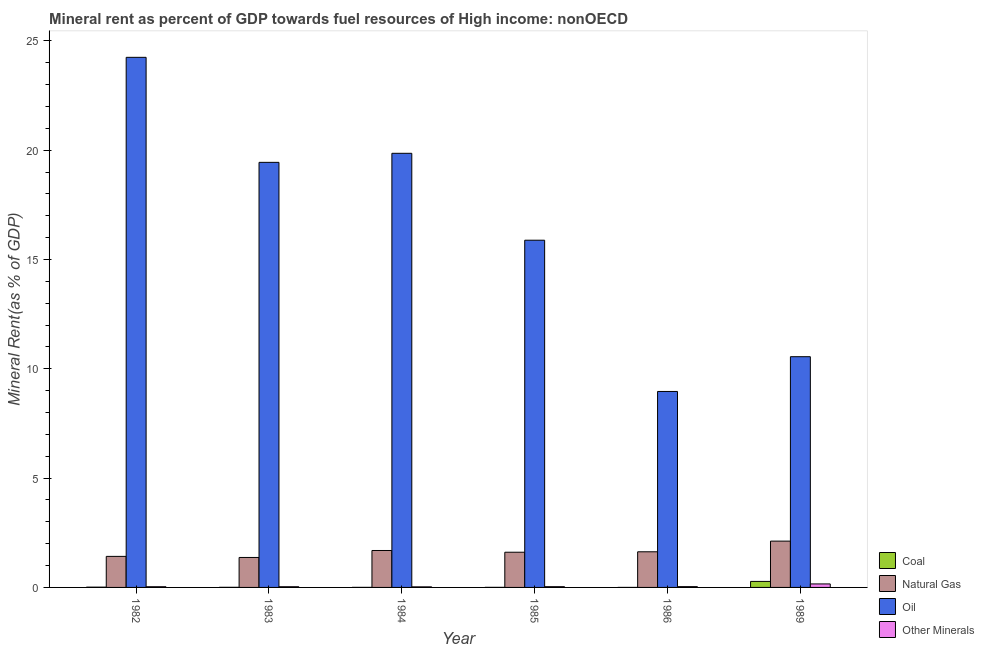How many groups of bars are there?
Keep it short and to the point. 6. Are the number of bars on each tick of the X-axis equal?
Ensure brevity in your answer.  Yes. How many bars are there on the 1st tick from the left?
Your answer should be very brief. 4. How many bars are there on the 3rd tick from the right?
Provide a succinct answer. 4. What is the label of the 1st group of bars from the left?
Your answer should be compact. 1982. In how many cases, is the number of bars for a given year not equal to the number of legend labels?
Your answer should be very brief. 0. What is the oil rent in 1986?
Keep it short and to the point. 8.96. Across all years, what is the maximum natural gas rent?
Keep it short and to the point. 2.12. Across all years, what is the minimum natural gas rent?
Your answer should be compact. 1.37. In which year was the natural gas rent maximum?
Make the answer very short. 1989. What is the total oil rent in the graph?
Offer a terse response. 98.95. What is the difference between the coal rent in 1983 and that in 1986?
Offer a very short reply. 0. What is the difference between the coal rent in 1989 and the oil rent in 1984?
Your answer should be compact. 0.27. What is the average  rent of other minerals per year?
Make the answer very short. 0.05. In the year 1989, what is the difference between the  rent of other minerals and natural gas rent?
Your answer should be very brief. 0. What is the ratio of the coal rent in 1984 to that in 1989?
Offer a terse response. 0.01. Is the coal rent in 1983 less than that in 1986?
Provide a short and direct response. No. What is the difference between the highest and the second highest natural gas rent?
Your response must be concise. 0.43. What is the difference between the highest and the lowest natural gas rent?
Provide a short and direct response. 0.75. In how many years, is the natural gas rent greater than the average natural gas rent taken over all years?
Your response must be concise. 2. Is the sum of the oil rent in 1985 and 1986 greater than the maximum coal rent across all years?
Offer a terse response. Yes. Is it the case that in every year, the sum of the oil rent and coal rent is greater than the sum of natural gas rent and  rent of other minerals?
Ensure brevity in your answer.  Yes. What does the 4th bar from the left in 1989 represents?
Make the answer very short. Other Minerals. What does the 3rd bar from the right in 1982 represents?
Your answer should be compact. Natural Gas. Is it the case that in every year, the sum of the coal rent and natural gas rent is greater than the oil rent?
Your answer should be very brief. No. How many years are there in the graph?
Ensure brevity in your answer.  6. What is the difference between two consecutive major ticks on the Y-axis?
Offer a very short reply. 5. Are the values on the major ticks of Y-axis written in scientific E-notation?
Your answer should be compact. No. Does the graph contain grids?
Your response must be concise. No. What is the title of the graph?
Offer a very short reply. Mineral rent as percent of GDP towards fuel resources of High income: nonOECD. What is the label or title of the Y-axis?
Your answer should be very brief. Mineral Rent(as % of GDP). What is the Mineral Rent(as % of GDP) of Coal in 1982?
Your answer should be compact. 0.01. What is the Mineral Rent(as % of GDP) of Natural Gas in 1982?
Offer a terse response. 1.42. What is the Mineral Rent(as % of GDP) of Oil in 1982?
Your answer should be very brief. 24.25. What is the Mineral Rent(as % of GDP) of Other Minerals in 1982?
Make the answer very short. 0.03. What is the Mineral Rent(as % of GDP) in Coal in 1983?
Offer a very short reply. 0. What is the Mineral Rent(as % of GDP) in Natural Gas in 1983?
Your response must be concise. 1.37. What is the Mineral Rent(as % of GDP) in Oil in 1983?
Your answer should be very brief. 19.44. What is the Mineral Rent(as % of GDP) in Other Minerals in 1983?
Make the answer very short. 0.03. What is the Mineral Rent(as % of GDP) of Coal in 1984?
Your response must be concise. 0. What is the Mineral Rent(as % of GDP) of Natural Gas in 1984?
Make the answer very short. 1.69. What is the Mineral Rent(as % of GDP) in Oil in 1984?
Make the answer very short. 19.86. What is the Mineral Rent(as % of GDP) in Other Minerals in 1984?
Keep it short and to the point. 0.03. What is the Mineral Rent(as % of GDP) in Coal in 1985?
Offer a very short reply. 0. What is the Mineral Rent(as % of GDP) of Natural Gas in 1985?
Your answer should be compact. 1.61. What is the Mineral Rent(as % of GDP) of Oil in 1985?
Your response must be concise. 15.88. What is the Mineral Rent(as % of GDP) in Other Minerals in 1985?
Offer a very short reply. 0.03. What is the Mineral Rent(as % of GDP) of Coal in 1986?
Give a very brief answer. 0. What is the Mineral Rent(as % of GDP) in Natural Gas in 1986?
Make the answer very short. 1.63. What is the Mineral Rent(as % of GDP) in Oil in 1986?
Keep it short and to the point. 8.96. What is the Mineral Rent(as % of GDP) of Other Minerals in 1986?
Your answer should be very brief. 0.04. What is the Mineral Rent(as % of GDP) in Coal in 1989?
Ensure brevity in your answer.  0.27. What is the Mineral Rent(as % of GDP) of Natural Gas in 1989?
Ensure brevity in your answer.  2.12. What is the Mineral Rent(as % of GDP) in Oil in 1989?
Keep it short and to the point. 10.55. What is the Mineral Rent(as % of GDP) in Other Minerals in 1989?
Offer a very short reply. 0.16. Across all years, what is the maximum Mineral Rent(as % of GDP) in Coal?
Give a very brief answer. 0.27. Across all years, what is the maximum Mineral Rent(as % of GDP) of Natural Gas?
Give a very brief answer. 2.12. Across all years, what is the maximum Mineral Rent(as % of GDP) in Oil?
Provide a short and direct response. 24.25. Across all years, what is the maximum Mineral Rent(as % of GDP) in Other Minerals?
Keep it short and to the point. 0.16. Across all years, what is the minimum Mineral Rent(as % of GDP) of Coal?
Offer a very short reply. 0. Across all years, what is the minimum Mineral Rent(as % of GDP) in Natural Gas?
Provide a succinct answer. 1.37. Across all years, what is the minimum Mineral Rent(as % of GDP) of Oil?
Your answer should be very brief. 8.96. Across all years, what is the minimum Mineral Rent(as % of GDP) of Other Minerals?
Your answer should be compact. 0.03. What is the total Mineral Rent(as % of GDP) in Coal in the graph?
Provide a succinct answer. 0.3. What is the total Mineral Rent(as % of GDP) in Natural Gas in the graph?
Offer a terse response. 9.84. What is the total Mineral Rent(as % of GDP) in Oil in the graph?
Ensure brevity in your answer.  98.95. What is the total Mineral Rent(as % of GDP) in Other Minerals in the graph?
Keep it short and to the point. 0.32. What is the difference between the Mineral Rent(as % of GDP) of Coal in 1982 and that in 1983?
Offer a terse response. 0.01. What is the difference between the Mineral Rent(as % of GDP) in Natural Gas in 1982 and that in 1983?
Provide a succinct answer. 0.05. What is the difference between the Mineral Rent(as % of GDP) in Oil in 1982 and that in 1983?
Offer a terse response. 4.8. What is the difference between the Mineral Rent(as % of GDP) of Coal in 1982 and that in 1984?
Offer a very short reply. 0.01. What is the difference between the Mineral Rent(as % of GDP) of Natural Gas in 1982 and that in 1984?
Your response must be concise. -0.27. What is the difference between the Mineral Rent(as % of GDP) in Oil in 1982 and that in 1984?
Your response must be concise. 4.39. What is the difference between the Mineral Rent(as % of GDP) of Other Minerals in 1982 and that in 1984?
Provide a succinct answer. 0.01. What is the difference between the Mineral Rent(as % of GDP) of Coal in 1982 and that in 1985?
Your response must be concise. 0.01. What is the difference between the Mineral Rent(as % of GDP) of Natural Gas in 1982 and that in 1985?
Keep it short and to the point. -0.19. What is the difference between the Mineral Rent(as % of GDP) in Oil in 1982 and that in 1985?
Your answer should be very brief. 8.36. What is the difference between the Mineral Rent(as % of GDP) in Other Minerals in 1982 and that in 1985?
Your answer should be very brief. -0. What is the difference between the Mineral Rent(as % of GDP) in Coal in 1982 and that in 1986?
Ensure brevity in your answer.  0.01. What is the difference between the Mineral Rent(as % of GDP) in Natural Gas in 1982 and that in 1986?
Offer a terse response. -0.21. What is the difference between the Mineral Rent(as % of GDP) in Oil in 1982 and that in 1986?
Make the answer very short. 15.28. What is the difference between the Mineral Rent(as % of GDP) in Other Minerals in 1982 and that in 1986?
Ensure brevity in your answer.  -0. What is the difference between the Mineral Rent(as % of GDP) in Coal in 1982 and that in 1989?
Give a very brief answer. -0.26. What is the difference between the Mineral Rent(as % of GDP) of Natural Gas in 1982 and that in 1989?
Ensure brevity in your answer.  -0.7. What is the difference between the Mineral Rent(as % of GDP) of Oil in 1982 and that in 1989?
Keep it short and to the point. 13.69. What is the difference between the Mineral Rent(as % of GDP) of Other Minerals in 1982 and that in 1989?
Your answer should be compact. -0.13. What is the difference between the Mineral Rent(as % of GDP) in Coal in 1983 and that in 1984?
Give a very brief answer. 0. What is the difference between the Mineral Rent(as % of GDP) of Natural Gas in 1983 and that in 1984?
Your answer should be compact. -0.32. What is the difference between the Mineral Rent(as % of GDP) of Oil in 1983 and that in 1984?
Offer a terse response. -0.41. What is the difference between the Mineral Rent(as % of GDP) in Other Minerals in 1983 and that in 1984?
Offer a very short reply. 0.01. What is the difference between the Mineral Rent(as % of GDP) in Coal in 1983 and that in 1985?
Your response must be concise. 0. What is the difference between the Mineral Rent(as % of GDP) in Natural Gas in 1983 and that in 1985?
Keep it short and to the point. -0.24. What is the difference between the Mineral Rent(as % of GDP) of Oil in 1983 and that in 1985?
Ensure brevity in your answer.  3.56. What is the difference between the Mineral Rent(as % of GDP) in Other Minerals in 1983 and that in 1985?
Your response must be concise. -0. What is the difference between the Mineral Rent(as % of GDP) of Coal in 1983 and that in 1986?
Make the answer very short. 0. What is the difference between the Mineral Rent(as % of GDP) in Natural Gas in 1983 and that in 1986?
Offer a very short reply. -0.26. What is the difference between the Mineral Rent(as % of GDP) of Oil in 1983 and that in 1986?
Offer a terse response. 10.48. What is the difference between the Mineral Rent(as % of GDP) in Other Minerals in 1983 and that in 1986?
Keep it short and to the point. -0. What is the difference between the Mineral Rent(as % of GDP) in Coal in 1983 and that in 1989?
Make the answer very short. -0.27. What is the difference between the Mineral Rent(as % of GDP) of Natural Gas in 1983 and that in 1989?
Offer a very short reply. -0.75. What is the difference between the Mineral Rent(as % of GDP) in Oil in 1983 and that in 1989?
Offer a very short reply. 8.89. What is the difference between the Mineral Rent(as % of GDP) in Other Minerals in 1983 and that in 1989?
Your answer should be compact. -0.13. What is the difference between the Mineral Rent(as % of GDP) in Coal in 1984 and that in 1985?
Your response must be concise. -0. What is the difference between the Mineral Rent(as % of GDP) in Natural Gas in 1984 and that in 1985?
Your response must be concise. 0.08. What is the difference between the Mineral Rent(as % of GDP) of Oil in 1984 and that in 1985?
Your answer should be very brief. 3.97. What is the difference between the Mineral Rent(as % of GDP) in Other Minerals in 1984 and that in 1985?
Offer a terse response. -0.01. What is the difference between the Mineral Rent(as % of GDP) in Coal in 1984 and that in 1986?
Your answer should be compact. 0. What is the difference between the Mineral Rent(as % of GDP) in Natural Gas in 1984 and that in 1986?
Your answer should be compact. 0.06. What is the difference between the Mineral Rent(as % of GDP) of Oil in 1984 and that in 1986?
Ensure brevity in your answer.  10.89. What is the difference between the Mineral Rent(as % of GDP) of Other Minerals in 1984 and that in 1986?
Provide a succinct answer. -0.01. What is the difference between the Mineral Rent(as % of GDP) in Coal in 1984 and that in 1989?
Your answer should be compact. -0.27. What is the difference between the Mineral Rent(as % of GDP) of Natural Gas in 1984 and that in 1989?
Provide a short and direct response. -0.43. What is the difference between the Mineral Rent(as % of GDP) of Oil in 1984 and that in 1989?
Your response must be concise. 9.3. What is the difference between the Mineral Rent(as % of GDP) in Other Minerals in 1984 and that in 1989?
Offer a terse response. -0.13. What is the difference between the Mineral Rent(as % of GDP) of Coal in 1985 and that in 1986?
Offer a terse response. 0. What is the difference between the Mineral Rent(as % of GDP) in Natural Gas in 1985 and that in 1986?
Provide a succinct answer. -0.02. What is the difference between the Mineral Rent(as % of GDP) of Oil in 1985 and that in 1986?
Give a very brief answer. 6.92. What is the difference between the Mineral Rent(as % of GDP) of Other Minerals in 1985 and that in 1986?
Make the answer very short. -0. What is the difference between the Mineral Rent(as % of GDP) in Coal in 1985 and that in 1989?
Your response must be concise. -0.27. What is the difference between the Mineral Rent(as % of GDP) in Natural Gas in 1985 and that in 1989?
Offer a very short reply. -0.51. What is the difference between the Mineral Rent(as % of GDP) of Oil in 1985 and that in 1989?
Make the answer very short. 5.33. What is the difference between the Mineral Rent(as % of GDP) of Other Minerals in 1985 and that in 1989?
Offer a terse response. -0.13. What is the difference between the Mineral Rent(as % of GDP) of Coal in 1986 and that in 1989?
Offer a terse response. -0.27. What is the difference between the Mineral Rent(as % of GDP) of Natural Gas in 1986 and that in 1989?
Offer a terse response. -0.49. What is the difference between the Mineral Rent(as % of GDP) in Oil in 1986 and that in 1989?
Provide a short and direct response. -1.59. What is the difference between the Mineral Rent(as % of GDP) of Other Minerals in 1986 and that in 1989?
Give a very brief answer. -0.12. What is the difference between the Mineral Rent(as % of GDP) in Coal in 1982 and the Mineral Rent(as % of GDP) in Natural Gas in 1983?
Your response must be concise. -1.36. What is the difference between the Mineral Rent(as % of GDP) of Coal in 1982 and the Mineral Rent(as % of GDP) of Oil in 1983?
Your response must be concise. -19.43. What is the difference between the Mineral Rent(as % of GDP) in Coal in 1982 and the Mineral Rent(as % of GDP) in Other Minerals in 1983?
Provide a succinct answer. -0.02. What is the difference between the Mineral Rent(as % of GDP) in Natural Gas in 1982 and the Mineral Rent(as % of GDP) in Oil in 1983?
Your answer should be very brief. -18.02. What is the difference between the Mineral Rent(as % of GDP) in Natural Gas in 1982 and the Mineral Rent(as % of GDP) in Other Minerals in 1983?
Offer a terse response. 1.39. What is the difference between the Mineral Rent(as % of GDP) of Oil in 1982 and the Mineral Rent(as % of GDP) of Other Minerals in 1983?
Your answer should be compact. 24.21. What is the difference between the Mineral Rent(as % of GDP) of Coal in 1982 and the Mineral Rent(as % of GDP) of Natural Gas in 1984?
Provide a succinct answer. -1.68. What is the difference between the Mineral Rent(as % of GDP) of Coal in 1982 and the Mineral Rent(as % of GDP) of Oil in 1984?
Provide a short and direct response. -19.84. What is the difference between the Mineral Rent(as % of GDP) in Coal in 1982 and the Mineral Rent(as % of GDP) in Other Minerals in 1984?
Provide a succinct answer. -0.01. What is the difference between the Mineral Rent(as % of GDP) in Natural Gas in 1982 and the Mineral Rent(as % of GDP) in Oil in 1984?
Your answer should be compact. -18.44. What is the difference between the Mineral Rent(as % of GDP) in Natural Gas in 1982 and the Mineral Rent(as % of GDP) in Other Minerals in 1984?
Ensure brevity in your answer.  1.39. What is the difference between the Mineral Rent(as % of GDP) in Oil in 1982 and the Mineral Rent(as % of GDP) in Other Minerals in 1984?
Keep it short and to the point. 24.22. What is the difference between the Mineral Rent(as % of GDP) of Coal in 1982 and the Mineral Rent(as % of GDP) of Natural Gas in 1985?
Your answer should be very brief. -1.6. What is the difference between the Mineral Rent(as % of GDP) in Coal in 1982 and the Mineral Rent(as % of GDP) in Oil in 1985?
Offer a terse response. -15.87. What is the difference between the Mineral Rent(as % of GDP) of Coal in 1982 and the Mineral Rent(as % of GDP) of Other Minerals in 1985?
Offer a very short reply. -0.02. What is the difference between the Mineral Rent(as % of GDP) of Natural Gas in 1982 and the Mineral Rent(as % of GDP) of Oil in 1985?
Provide a succinct answer. -14.46. What is the difference between the Mineral Rent(as % of GDP) of Natural Gas in 1982 and the Mineral Rent(as % of GDP) of Other Minerals in 1985?
Provide a short and direct response. 1.39. What is the difference between the Mineral Rent(as % of GDP) of Oil in 1982 and the Mineral Rent(as % of GDP) of Other Minerals in 1985?
Your answer should be very brief. 24.21. What is the difference between the Mineral Rent(as % of GDP) in Coal in 1982 and the Mineral Rent(as % of GDP) in Natural Gas in 1986?
Your answer should be compact. -1.62. What is the difference between the Mineral Rent(as % of GDP) of Coal in 1982 and the Mineral Rent(as % of GDP) of Oil in 1986?
Offer a terse response. -8.95. What is the difference between the Mineral Rent(as % of GDP) of Coal in 1982 and the Mineral Rent(as % of GDP) of Other Minerals in 1986?
Offer a terse response. -0.02. What is the difference between the Mineral Rent(as % of GDP) in Natural Gas in 1982 and the Mineral Rent(as % of GDP) in Oil in 1986?
Keep it short and to the point. -7.54. What is the difference between the Mineral Rent(as % of GDP) of Natural Gas in 1982 and the Mineral Rent(as % of GDP) of Other Minerals in 1986?
Your response must be concise. 1.38. What is the difference between the Mineral Rent(as % of GDP) in Oil in 1982 and the Mineral Rent(as % of GDP) in Other Minerals in 1986?
Keep it short and to the point. 24.21. What is the difference between the Mineral Rent(as % of GDP) in Coal in 1982 and the Mineral Rent(as % of GDP) in Natural Gas in 1989?
Give a very brief answer. -2.11. What is the difference between the Mineral Rent(as % of GDP) of Coal in 1982 and the Mineral Rent(as % of GDP) of Oil in 1989?
Provide a succinct answer. -10.54. What is the difference between the Mineral Rent(as % of GDP) of Coal in 1982 and the Mineral Rent(as % of GDP) of Other Minerals in 1989?
Ensure brevity in your answer.  -0.15. What is the difference between the Mineral Rent(as % of GDP) in Natural Gas in 1982 and the Mineral Rent(as % of GDP) in Oil in 1989?
Provide a succinct answer. -9.13. What is the difference between the Mineral Rent(as % of GDP) in Natural Gas in 1982 and the Mineral Rent(as % of GDP) in Other Minerals in 1989?
Provide a short and direct response. 1.26. What is the difference between the Mineral Rent(as % of GDP) in Oil in 1982 and the Mineral Rent(as % of GDP) in Other Minerals in 1989?
Provide a succinct answer. 24.09. What is the difference between the Mineral Rent(as % of GDP) of Coal in 1983 and the Mineral Rent(as % of GDP) of Natural Gas in 1984?
Offer a very short reply. -1.68. What is the difference between the Mineral Rent(as % of GDP) in Coal in 1983 and the Mineral Rent(as % of GDP) in Oil in 1984?
Your answer should be compact. -19.85. What is the difference between the Mineral Rent(as % of GDP) in Coal in 1983 and the Mineral Rent(as % of GDP) in Other Minerals in 1984?
Make the answer very short. -0.02. What is the difference between the Mineral Rent(as % of GDP) in Natural Gas in 1983 and the Mineral Rent(as % of GDP) in Oil in 1984?
Make the answer very short. -18.49. What is the difference between the Mineral Rent(as % of GDP) of Natural Gas in 1983 and the Mineral Rent(as % of GDP) of Other Minerals in 1984?
Keep it short and to the point. 1.34. What is the difference between the Mineral Rent(as % of GDP) in Oil in 1983 and the Mineral Rent(as % of GDP) in Other Minerals in 1984?
Keep it short and to the point. 19.42. What is the difference between the Mineral Rent(as % of GDP) in Coal in 1983 and the Mineral Rent(as % of GDP) in Natural Gas in 1985?
Offer a very short reply. -1.61. What is the difference between the Mineral Rent(as % of GDP) in Coal in 1983 and the Mineral Rent(as % of GDP) in Oil in 1985?
Give a very brief answer. -15.88. What is the difference between the Mineral Rent(as % of GDP) of Coal in 1983 and the Mineral Rent(as % of GDP) of Other Minerals in 1985?
Offer a terse response. -0.03. What is the difference between the Mineral Rent(as % of GDP) of Natural Gas in 1983 and the Mineral Rent(as % of GDP) of Oil in 1985?
Offer a terse response. -14.51. What is the difference between the Mineral Rent(as % of GDP) in Natural Gas in 1983 and the Mineral Rent(as % of GDP) in Other Minerals in 1985?
Your answer should be compact. 1.34. What is the difference between the Mineral Rent(as % of GDP) of Oil in 1983 and the Mineral Rent(as % of GDP) of Other Minerals in 1985?
Give a very brief answer. 19.41. What is the difference between the Mineral Rent(as % of GDP) in Coal in 1983 and the Mineral Rent(as % of GDP) in Natural Gas in 1986?
Give a very brief answer. -1.63. What is the difference between the Mineral Rent(as % of GDP) of Coal in 1983 and the Mineral Rent(as % of GDP) of Oil in 1986?
Offer a terse response. -8.96. What is the difference between the Mineral Rent(as % of GDP) in Coal in 1983 and the Mineral Rent(as % of GDP) in Other Minerals in 1986?
Make the answer very short. -0.03. What is the difference between the Mineral Rent(as % of GDP) in Natural Gas in 1983 and the Mineral Rent(as % of GDP) in Oil in 1986?
Give a very brief answer. -7.59. What is the difference between the Mineral Rent(as % of GDP) of Natural Gas in 1983 and the Mineral Rent(as % of GDP) of Other Minerals in 1986?
Offer a terse response. 1.33. What is the difference between the Mineral Rent(as % of GDP) in Oil in 1983 and the Mineral Rent(as % of GDP) in Other Minerals in 1986?
Make the answer very short. 19.41. What is the difference between the Mineral Rent(as % of GDP) in Coal in 1983 and the Mineral Rent(as % of GDP) in Natural Gas in 1989?
Offer a very short reply. -2.11. What is the difference between the Mineral Rent(as % of GDP) of Coal in 1983 and the Mineral Rent(as % of GDP) of Oil in 1989?
Ensure brevity in your answer.  -10.55. What is the difference between the Mineral Rent(as % of GDP) of Coal in 1983 and the Mineral Rent(as % of GDP) of Other Minerals in 1989?
Provide a short and direct response. -0.16. What is the difference between the Mineral Rent(as % of GDP) of Natural Gas in 1983 and the Mineral Rent(as % of GDP) of Oil in 1989?
Provide a short and direct response. -9.18. What is the difference between the Mineral Rent(as % of GDP) in Natural Gas in 1983 and the Mineral Rent(as % of GDP) in Other Minerals in 1989?
Ensure brevity in your answer.  1.21. What is the difference between the Mineral Rent(as % of GDP) of Oil in 1983 and the Mineral Rent(as % of GDP) of Other Minerals in 1989?
Give a very brief answer. 19.28. What is the difference between the Mineral Rent(as % of GDP) of Coal in 1984 and the Mineral Rent(as % of GDP) of Natural Gas in 1985?
Make the answer very short. -1.61. What is the difference between the Mineral Rent(as % of GDP) in Coal in 1984 and the Mineral Rent(as % of GDP) in Oil in 1985?
Offer a terse response. -15.88. What is the difference between the Mineral Rent(as % of GDP) of Coal in 1984 and the Mineral Rent(as % of GDP) of Other Minerals in 1985?
Your answer should be very brief. -0.03. What is the difference between the Mineral Rent(as % of GDP) of Natural Gas in 1984 and the Mineral Rent(as % of GDP) of Oil in 1985?
Keep it short and to the point. -14.19. What is the difference between the Mineral Rent(as % of GDP) in Natural Gas in 1984 and the Mineral Rent(as % of GDP) in Other Minerals in 1985?
Make the answer very short. 1.66. What is the difference between the Mineral Rent(as % of GDP) of Oil in 1984 and the Mineral Rent(as % of GDP) of Other Minerals in 1985?
Your answer should be very brief. 19.82. What is the difference between the Mineral Rent(as % of GDP) in Coal in 1984 and the Mineral Rent(as % of GDP) in Natural Gas in 1986?
Offer a terse response. -1.63. What is the difference between the Mineral Rent(as % of GDP) in Coal in 1984 and the Mineral Rent(as % of GDP) in Oil in 1986?
Offer a very short reply. -8.96. What is the difference between the Mineral Rent(as % of GDP) of Coal in 1984 and the Mineral Rent(as % of GDP) of Other Minerals in 1986?
Provide a short and direct response. -0.03. What is the difference between the Mineral Rent(as % of GDP) in Natural Gas in 1984 and the Mineral Rent(as % of GDP) in Oil in 1986?
Ensure brevity in your answer.  -7.27. What is the difference between the Mineral Rent(as % of GDP) in Natural Gas in 1984 and the Mineral Rent(as % of GDP) in Other Minerals in 1986?
Offer a very short reply. 1.65. What is the difference between the Mineral Rent(as % of GDP) in Oil in 1984 and the Mineral Rent(as % of GDP) in Other Minerals in 1986?
Offer a very short reply. 19.82. What is the difference between the Mineral Rent(as % of GDP) in Coal in 1984 and the Mineral Rent(as % of GDP) in Natural Gas in 1989?
Offer a terse response. -2.12. What is the difference between the Mineral Rent(as % of GDP) of Coal in 1984 and the Mineral Rent(as % of GDP) of Oil in 1989?
Ensure brevity in your answer.  -10.55. What is the difference between the Mineral Rent(as % of GDP) of Coal in 1984 and the Mineral Rent(as % of GDP) of Other Minerals in 1989?
Your answer should be compact. -0.16. What is the difference between the Mineral Rent(as % of GDP) of Natural Gas in 1984 and the Mineral Rent(as % of GDP) of Oil in 1989?
Your response must be concise. -8.86. What is the difference between the Mineral Rent(as % of GDP) of Natural Gas in 1984 and the Mineral Rent(as % of GDP) of Other Minerals in 1989?
Your response must be concise. 1.53. What is the difference between the Mineral Rent(as % of GDP) of Oil in 1984 and the Mineral Rent(as % of GDP) of Other Minerals in 1989?
Your answer should be very brief. 19.7. What is the difference between the Mineral Rent(as % of GDP) of Coal in 1985 and the Mineral Rent(as % of GDP) of Natural Gas in 1986?
Offer a very short reply. -1.63. What is the difference between the Mineral Rent(as % of GDP) in Coal in 1985 and the Mineral Rent(as % of GDP) in Oil in 1986?
Your answer should be very brief. -8.96. What is the difference between the Mineral Rent(as % of GDP) in Coal in 1985 and the Mineral Rent(as % of GDP) in Other Minerals in 1986?
Offer a very short reply. -0.03. What is the difference between the Mineral Rent(as % of GDP) of Natural Gas in 1985 and the Mineral Rent(as % of GDP) of Oil in 1986?
Give a very brief answer. -7.35. What is the difference between the Mineral Rent(as % of GDP) in Natural Gas in 1985 and the Mineral Rent(as % of GDP) in Other Minerals in 1986?
Your answer should be very brief. 1.57. What is the difference between the Mineral Rent(as % of GDP) in Oil in 1985 and the Mineral Rent(as % of GDP) in Other Minerals in 1986?
Provide a succinct answer. 15.85. What is the difference between the Mineral Rent(as % of GDP) in Coal in 1985 and the Mineral Rent(as % of GDP) in Natural Gas in 1989?
Offer a very short reply. -2.11. What is the difference between the Mineral Rent(as % of GDP) of Coal in 1985 and the Mineral Rent(as % of GDP) of Oil in 1989?
Make the answer very short. -10.55. What is the difference between the Mineral Rent(as % of GDP) of Coal in 1985 and the Mineral Rent(as % of GDP) of Other Minerals in 1989?
Provide a short and direct response. -0.16. What is the difference between the Mineral Rent(as % of GDP) of Natural Gas in 1985 and the Mineral Rent(as % of GDP) of Oil in 1989?
Your answer should be very brief. -8.94. What is the difference between the Mineral Rent(as % of GDP) of Natural Gas in 1985 and the Mineral Rent(as % of GDP) of Other Minerals in 1989?
Offer a terse response. 1.45. What is the difference between the Mineral Rent(as % of GDP) of Oil in 1985 and the Mineral Rent(as % of GDP) of Other Minerals in 1989?
Provide a short and direct response. 15.72. What is the difference between the Mineral Rent(as % of GDP) in Coal in 1986 and the Mineral Rent(as % of GDP) in Natural Gas in 1989?
Your response must be concise. -2.12. What is the difference between the Mineral Rent(as % of GDP) in Coal in 1986 and the Mineral Rent(as % of GDP) in Oil in 1989?
Make the answer very short. -10.55. What is the difference between the Mineral Rent(as % of GDP) in Coal in 1986 and the Mineral Rent(as % of GDP) in Other Minerals in 1989?
Provide a short and direct response. -0.16. What is the difference between the Mineral Rent(as % of GDP) in Natural Gas in 1986 and the Mineral Rent(as % of GDP) in Oil in 1989?
Your answer should be compact. -8.92. What is the difference between the Mineral Rent(as % of GDP) of Natural Gas in 1986 and the Mineral Rent(as % of GDP) of Other Minerals in 1989?
Your answer should be compact. 1.47. What is the difference between the Mineral Rent(as % of GDP) of Oil in 1986 and the Mineral Rent(as % of GDP) of Other Minerals in 1989?
Provide a short and direct response. 8.8. What is the average Mineral Rent(as % of GDP) in Coal per year?
Your answer should be very brief. 0.05. What is the average Mineral Rent(as % of GDP) of Natural Gas per year?
Your answer should be very brief. 1.64. What is the average Mineral Rent(as % of GDP) of Oil per year?
Your answer should be compact. 16.49. What is the average Mineral Rent(as % of GDP) of Other Minerals per year?
Ensure brevity in your answer.  0.05. In the year 1982, what is the difference between the Mineral Rent(as % of GDP) of Coal and Mineral Rent(as % of GDP) of Natural Gas?
Ensure brevity in your answer.  -1.41. In the year 1982, what is the difference between the Mineral Rent(as % of GDP) in Coal and Mineral Rent(as % of GDP) in Oil?
Offer a terse response. -24.23. In the year 1982, what is the difference between the Mineral Rent(as % of GDP) of Coal and Mineral Rent(as % of GDP) of Other Minerals?
Offer a terse response. -0.02. In the year 1982, what is the difference between the Mineral Rent(as % of GDP) in Natural Gas and Mineral Rent(as % of GDP) in Oil?
Your response must be concise. -22.83. In the year 1982, what is the difference between the Mineral Rent(as % of GDP) of Natural Gas and Mineral Rent(as % of GDP) of Other Minerals?
Offer a very short reply. 1.39. In the year 1982, what is the difference between the Mineral Rent(as % of GDP) in Oil and Mineral Rent(as % of GDP) in Other Minerals?
Your answer should be very brief. 24.21. In the year 1983, what is the difference between the Mineral Rent(as % of GDP) in Coal and Mineral Rent(as % of GDP) in Natural Gas?
Make the answer very short. -1.37. In the year 1983, what is the difference between the Mineral Rent(as % of GDP) of Coal and Mineral Rent(as % of GDP) of Oil?
Offer a terse response. -19.44. In the year 1983, what is the difference between the Mineral Rent(as % of GDP) in Coal and Mineral Rent(as % of GDP) in Other Minerals?
Your answer should be very brief. -0.03. In the year 1983, what is the difference between the Mineral Rent(as % of GDP) in Natural Gas and Mineral Rent(as % of GDP) in Oil?
Ensure brevity in your answer.  -18.07. In the year 1983, what is the difference between the Mineral Rent(as % of GDP) of Natural Gas and Mineral Rent(as % of GDP) of Other Minerals?
Provide a succinct answer. 1.34. In the year 1983, what is the difference between the Mineral Rent(as % of GDP) in Oil and Mineral Rent(as % of GDP) in Other Minerals?
Give a very brief answer. 19.41. In the year 1984, what is the difference between the Mineral Rent(as % of GDP) of Coal and Mineral Rent(as % of GDP) of Natural Gas?
Give a very brief answer. -1.69. In the year 1984, what is the difference between the Mineral Rent(as % of GDP) in Coal and Mineral Rent(as % of GDP) in Oil?
Offer a terse response. -19.85. In the year 1984, what is the difference between the Mineral Rent(as % of GDP) in Coal and Mineral Rent(as % of GDP) in Other Minerals?
Offer a very short reply. -0.02. In the year 1984, what is the difference between the Mineral Rent(as % of GDP) in Natural Gas and Mineral Rent(as % of GDP) in Oil?
Make the answer very short. -18.17. In the year 1984, what is the difference between the Mineral Rent(as % of GDP) of Natural Gas and Mineral Rent(as % of GDP) of Other Minerals?
Your answer should be very brief. 1.66. In the year 1984, what is the difference between the Mineral Rent(as % of GDP) in Oil and Mineral Rent(as % of GDP) in Other Minerals?
Your response must be concise. 19.83. In the year 1985, what is the difference between the Mineral Rent(as % of GDP) of Coal and Mineral Rent(as % of GDP) of Natural Gas?
Give a very brief answer. -1.61. In the year 1985, what is the difference between the Mineral Rent(as % of GDP) of Coal and Mineral Rent(as % of GDP) of Oil?
Provide a succinct answer. -15.88. In the year 1985, what is the difference between the Mineral Rent(as % of GDP) of Coal and Mineral Rent(as % of GDP) of Other Minerals?
Make the answer very short. -0.03. In the year 1985, what is the difference between the Mineral Rent(as % of GDP) in Natural Gas and Mineral Rent(as % of GDP) in Oil?
Ensure brevity in your answer.  -14.27. In the year 1985, what is the difference between the Mineral Rent(as % of GDP) in Natural Gas and Mineral Rent(as % of GDP) in Other Minerals?
Offer a terse response. 1.58. In the year 1985, what is the difference between the Mineral Rent(as % of GDP) in Oil and Mineral Rent(as % of GDP) in Other Minerals?
Your response must be concise. 15.85. In the year 1986, what is the difference between the Mineral Rent(as % of GDP) of Coal and Mineral Rent(as % of GDP) of Natural Gas?
Offer a terse response. -1.63. In the year 1986, what is the difference between the Mineral Rent(as % of GDP) in Coal and Mineral Rent(as % of GDP) in Oil?
Your answer should be very brief. -8.96. In the year 1986, what is the difference between the Mineral Rent(as % of GDP) in Coal and Mineral Rent(as % of GDP) in Other Minerals?
Make the answer very short. -0.04. In the year 1986, what is the difference between the Mineral Rent(as % of GDP) of Natural Gas and Mineral Rent(as % of GDP) of Oil?
Provide a succinct answer. -7.33. In the year 1986, what is the difference between the Mineral Rent(as % of GDP) in Natural Gas and Mineral Rent(as % of GDP) in Other Minerals?
Keep it short and to the point. 1.59. In the year 1986, what is the difference between the Mineral Rent(as % of GDP) of Oil and Mineral Rent(as % of GDP) of Other Minerals?
Your answer should be very brief. 8.93. In the year 1989, what is the difference between the Mineral Rent(as % of GDP) of Coal and Mineral Rent(as % of GDP) of Natural Gas?
Make the answer very short. -1.84. In the year 1989, what is the difference between the Mineral Rent(as % of GDP) in Coal and Mineral Rent(as % of GDP) in Oil?
Offer a terse response. -10.28. In the year 1989, what is the difference between the Mineral Rent(as % of GDP) of Coal and Mineral Rent(as % of GDP) of Other Minerals?
Provide a succinct answer. 0.11. In the year 1989, what is the difference between the Mineral Rent(as % of GDP) of Natural Gas and Mineral Rent(as % of GDP) of Oil?
Provide a succinct answer. -8.44. In the year 1989, what is the difference between the Mineral Rent(as % of GDP) of Natural Gas and Mineral Rent(as % of GDP) of Other Minerals?
Offer a very short reply. 1.96. In the year 1989, what is the difference between the Mineral Rent(as % of GDP) of Oil and Mineral Rent(as % of GDP) of Other Minerals?
Your answer should be very brief. 10.39. What is the ratio of the Mineral Rent(as % of GDP) in Coal in 1982 to that in 1983?
Ensure brevity in your answer.  2.71. What is the ratio of the Mineral Rent(as % of GDP) in Natural Gas in 1982 to that in 1983?
Your answer should be compact. 1.04. What is the ratio of the Mineral Rent(as % of GDP) in Oil in 1982 to that in 1983?
Provide a succinct answer. 1.25. What is the ratio of the Mineral Rent(as % of GDP) in Other Minerals in 1982 to that in 1983?
Your response must be concise. 1. What is the ratio of the Mineral Rent(as % of GDP) of Coal in 1982 to that in 1984?
Your answer should be compact. 5.28. What is the ratio of the Mineral Rent(as % of GDP) in Natural Gas in 1982 to that in 1984?
Offer a terse response. 0.84. What is the ratio of the Mineral Rent(as % of GDP) of Oil in 1982 to that in 1984?
Provide a short and direct response. 1.22. What is the ratio of the Mineral Rent(as % of GDP) of Other Minerals in 1982 to that in 1984?
Your answer should be very brief. 1.24. What is the ratio of the Mineral Rent(as % of GDP) in Coal in 1982 to that in 1985?
Provide a succinct answer. 3.84. What is the ratio of the Mineral Rent(as % of GDP) of Natural Gas in 1982 to that in 1985?
Your answer should be compact. 0.88. What is the ratio of the Mineral Rent(as % of GDP) in Oil in 1982 to that in 1985?
Provide a short and direct response. 1.53. What is the ratio of the Mineral Rent(as % of GDP) in Other Minerals in 1982 to that in 1985?
Ensure brevity in your answer.  0.94. What is the ratio of the Mineral Rent(as % of GDP) of Coal in 1982 to that in 1986?
Provide a succinct answer. 24.49. What is the ratio of the Mineral Rent(as % of GDP) in Natural Gas in 1982 to that in 1986?
Offer a terse response. 0.87. What is the ratio of the Mineral Rent(as % of GDP) in Oil in 1982 to that in 1986?
Give a very brief answer. 2.7. What is the ratio of the Mineral Rent(as % of GDP) of Other Minerals in 1982 to that in 1986?
Keep it short and to the point. 0.88. What is the ratio of the Mineral Rent(as % of GDP) in Coal in 1982 to that in 1989?
Your response must be concise. 0.05. What is the ratio of the Mineral Rent(as % of GDP) of Natural Gas in 1982 to that in 1989?
Provide a short and direct response. 0.67. What is the ratio of the Mineral Rent(as % of GDP) in Oil in 1982 to that in 1989?
Your answer should be very brief. 2.3. What is the ratio of the Mineral Rent(as % of GDP) of Other Minerals in 1982 to that in 1989?
Your response must be concise. 0.2. What is the ratio of the Mineral Rent(as % of GDP) in Coal in 1983 to that in 1984?
Your response must be concise. 1.95. What is the ratio of the Mineral Rent(as % of GDP) in Natural Gas in 1983 to that in 1984?
Your answer should be very brief. 0.81. What is the ratio of the Mineral Rent(as % of GDP) of Oil in 1983 to that in 1984?
Your answer should be very brief. 0.98. What is the ratio of the Mineral Rent(as % of GDP) in Other Minerals in 1983 to that in 1984?
Make the answer very short. 1.24. What is the ratio of the Mineral Rent(as % of GDP) in Coal in 1983 to that in 1985?
Offer a very short reply. 1.42. What is the ratio of the Mineral Rent(as % of GDP) in Natural Gas in 1983 to that in 1985?
Your response must be concise. 0.85. What is the ratio of the Mineral Rent(as % of GDP) in Oil in 1983 to that in 1985?
Provide a succinct answer. 1.22. What is the ratio of the Mineral Rent(as % of GDP) of Other Minerals in 1983 to that in 1985?
Ensure brevity in your answer.  0.94. What is the ratio of the Mineral Rent(as % of GDP) of Coal in 1983 to that in 1986?
Your response must be concise. 9.05. What is the ratio of the Mineral Rent(as % of GDP) of Natural Gas in 1983 to that in 1986?
Ensure brevity in your answer.  0.84. What is the ratio of the Mineral Rent(as % of GDP) of Oil in 1983 to that in 1986?
Your response must be concise. 2.17. What is the ratio of the Mineral Rent(as % of GDP) in Other Minerals in 1983 to that in 1986?
Your answer should be very brief. 0.88. What is the ratio of the Mineral Rent(as % of GDP) in Coal in 1983 to that in 1989?
Your response must be concise. 0.02. What is the ratio of the Mineral Rent(as % of GDP) in Natural Gas in 1983 to that in 1989?
Keep it short and to the point. 0.65. What is the ratio of the Mineral Rent(as % of GDP) in Oil in 1983 to that in 1989?
Provide a short and direct response. 1.84. What is the ratio of the Mineral Rent(as % of GDP) of Other Minerals in 1983 to that in 1989?
Provide a succinct answer. 0.2. What is the ratio of the Mineral Rent(as % of GDP) of Coal in 1984 to that in 1985?
Ensure brevity in your answer.  0.73. What is the ratio of the Mineral Rent(as % of GDP) in Natural Gas in 1984 to that in 1985?
Provide a short and direct response. 1.05. What is the ratio of the Mineral Rent(as % of GDP) of Oil in 1984 to that in 1985?
Offer a terse response. 1.25. What is the ratio of the Mineral Rent(as % of GDP) in Other Minerals in 1984 to that in 1985?
Provide a succinct answer. 0.76. What is the ratio of the Mineral Rent(as % of GDP) of Coal in 1984 to that in 1986?
Give a very brief answer. 4.64. What is the ratio of the Mineral Rent(as % of GDP) of Natural Gas in 1984 to that in 1986?
Offer a very short reply. 1.04. What is the ratio of the Mineral Rent(as % of GDP) of Oil in 1984 to that in 1986?
Offer a terse response. 2.22. What is the ratio of the Mineral Rent(as % of GDP) of Other Minerals in 1984 to that in 1986?
Offer a terse response. 0.71. What is the ratio of the Mineral Rent(as % of GDP) of Coal in 1984 to that in 1989?
Ensure brevity in your answer.  0.01. What is the ratio of the Mineral Rent(as % of GDP) in Natural Gas in 1984 to that in 1989?
Ensure brevity in your answer.  0.8. What is the ratio of the Mineral Rent(as % of GDP) in Oil in 1984 to that in 1989?
Ensure brevity in your answer.  1.88. What is the ratio of the Mineral Rent(as % of GDP) of Other Minerals in 1984 to that in 1989?
Your answer should be compact. 0.16. What is the ratio of the Mineral Rent(as % of GDP) of Coal in 1985 to that in 1986?
Offer a very short reply. 6.37. What is the ratio of the Mineral Rent(as % of GDP) in Natural Gas in 1985 to that in 1986?
Provide a short and direct response. 0.99. What is the ratio of the Mineral Rent(as % of GDP) in Oil in 1985 to that in 1986?
Your answer should be compact. 1.77. What is the ratio of the Mineral Rent(as % of GDP) in Other Minerals in 1985 to that in 1986?
Keep it short and to the point. 0.94. What is the ratio of the Mineral Rent(as % of GDP) in Coal in 1985 to that in 1989?
Give a very brief answer. 0.01. What is the ratio of the Mineral Rent(as % of GDP) in Natural Gas in 1985 to that in 1989?
Your response must be concise. 0.76. What is the ratio of the Mineral Rent(as % of GDP) of Oil in 1985 to that in 1989?
Ensure brevity in your answer.  1.5. What is the ratio of the Mineral Rent(as % of GDP) in Other Minerals in 1985 to that in 1989?
Your answer should be very brief. 0.21. What is the ratio of the Mineral Rent(as % of GDP) in Coal in 1986 to that in 1989?
Provide a succinct answer. 0. What is the ratio of the Mineral Rent(as % of GDP) of Natural Gas in 1986 to that in 1989?
Give a very brief answer. 0.77. What is the ratio of the Mineral Rent(as % of GDP) in Oil in 1986 to that in 1989?
Make the answer very short. 0.85. What is the ratio of the Mineral Rent(as % of GDP) in Other Minerals in 1986 to that in 1989?
Your answer should be compact. 0.23. What is the difference between the highest and the second highest Mineral Rent(as % of GDP) of Coal?
Your answer should be very brief. 0.26. What is the difference between the highest and the second highest Mineral Rent(as % of GDP) of Natural Gas?
Give a very brief answer. 0.43. What is the difference between the highest and the second highest Mineral Rent(as % of GDP) in Oil?
Offer a very short reply. 4.39. What is the difference between the highest and the second highest Mineral Rent(as % of GDP) in Other Minerals?
Make the answer very short. 0.12. What is the difference between the highest and the lowest Mineral Rent(as % of GDP) in Coal?
Your answer should be compact. 0.27. What is the difference between the highest and the lowest Mineral Rent(as % of GDP) of Natural Gas?
Ensure brevity in your answer.  0.75. What is the difference between the highest and the lowest Mineral Rent(as % of GDP) in Oil?
Your response must be concise. 15.28. What is the difference between the highest and the lowest Mineral Rent(as % of GDP) in Other Minerals?
Provide a succinct answer. 0.13. 